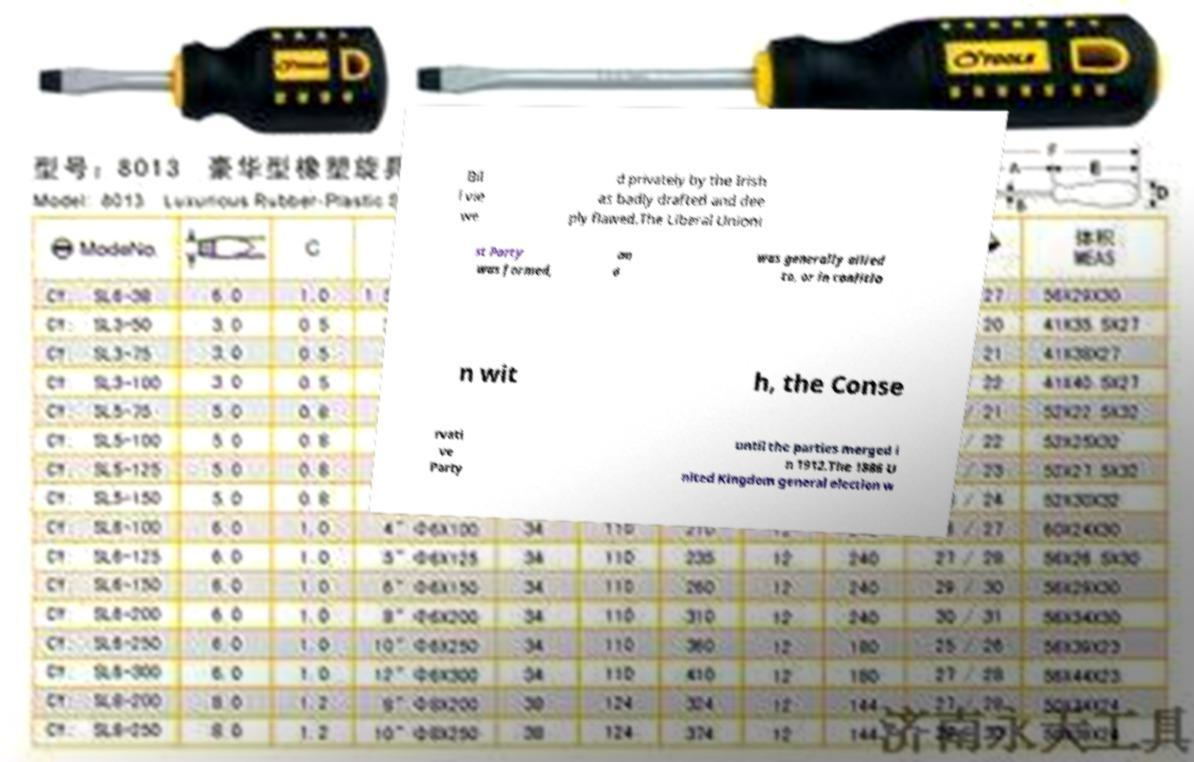Could you assist in decoding the text presented in this image and type it out clearly? Bil l vie we d privately by the Irish as badly drafted and dee ply flawed.The Liberal Unioni st Party was formed, an d was generally allied to, or in coalitio n wit h, the Conse rvati ve Party until the parties merged i n 1912.The 1886 U nited Kingdom general election w 